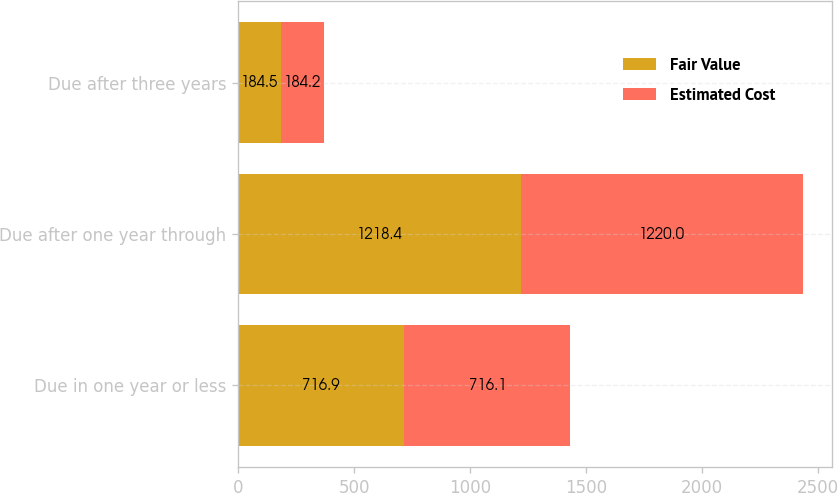Convert chart. <chart><loc_0><loc_0><loc_500><loc_500><stacked_bar_chart><ecel><fcel>Due in one year or less<fcel>Due after one year through<fcel>Due after three years<nl><fcel>Fair Value<fcel>716.9<fcel>1218.4<fcel>184.5<nl><fcel>Estimated Cost<fcel>716.1<fcel>1220<fcel>184.2<nl></chart> 